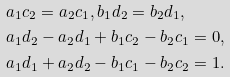Convert formula to latex. <formula><loc_0><loc_0><loc_500><loc_500>& a _ { 1 } c _ { 2 } = a _ { 2 } c _ { 1 } , b _ { 1 } d _ { 2 } = b _ { 2 } d _ { 1 } , \\ & a _ { 1 } d _ { 2 } - a _ { 2 } d _ { 1 } + b _ { 1 } c _ { 2 } - b _ { 2 } c _ { 1 } = 0 , \\ & a _ { 1 } d _ { 1 } + a _ { 2 } d _ { 2 } - b _ { 1 } c _ { 1 } - b _ { 2 } c _ { 2 } = 1 .</formula> 